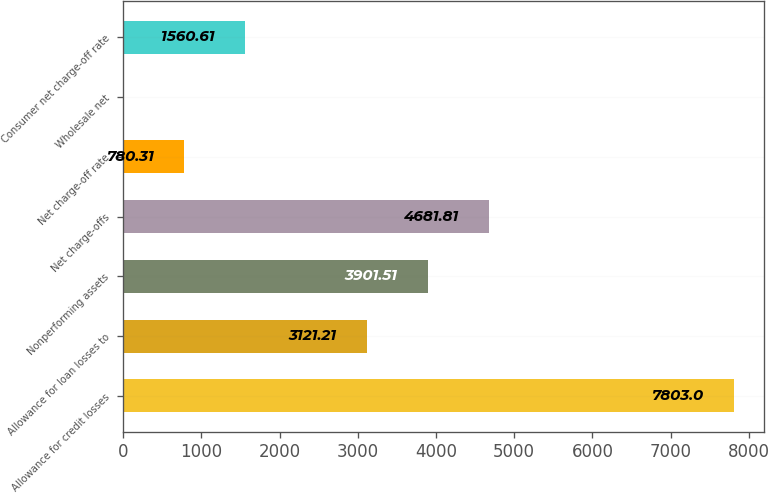Convert chart. <chart><loc_0><loc_0><loc_500><loc_500><bar_chart><fcel>Allowance for credit losses<fcel>Allowance for loan losses to<fcel>Nonperforming assets<fcel>Net charge-offs<fcel>Net charge-off rate<fcel>Wholesale net<fcel>Consumer net charge-off rate<nl><fcel>7803<fcel>3121.21<fcel>3901.51<fcel>4681.81<fcel>780.31<fcel>0.01<fcel>1560.61<nl></chart> 